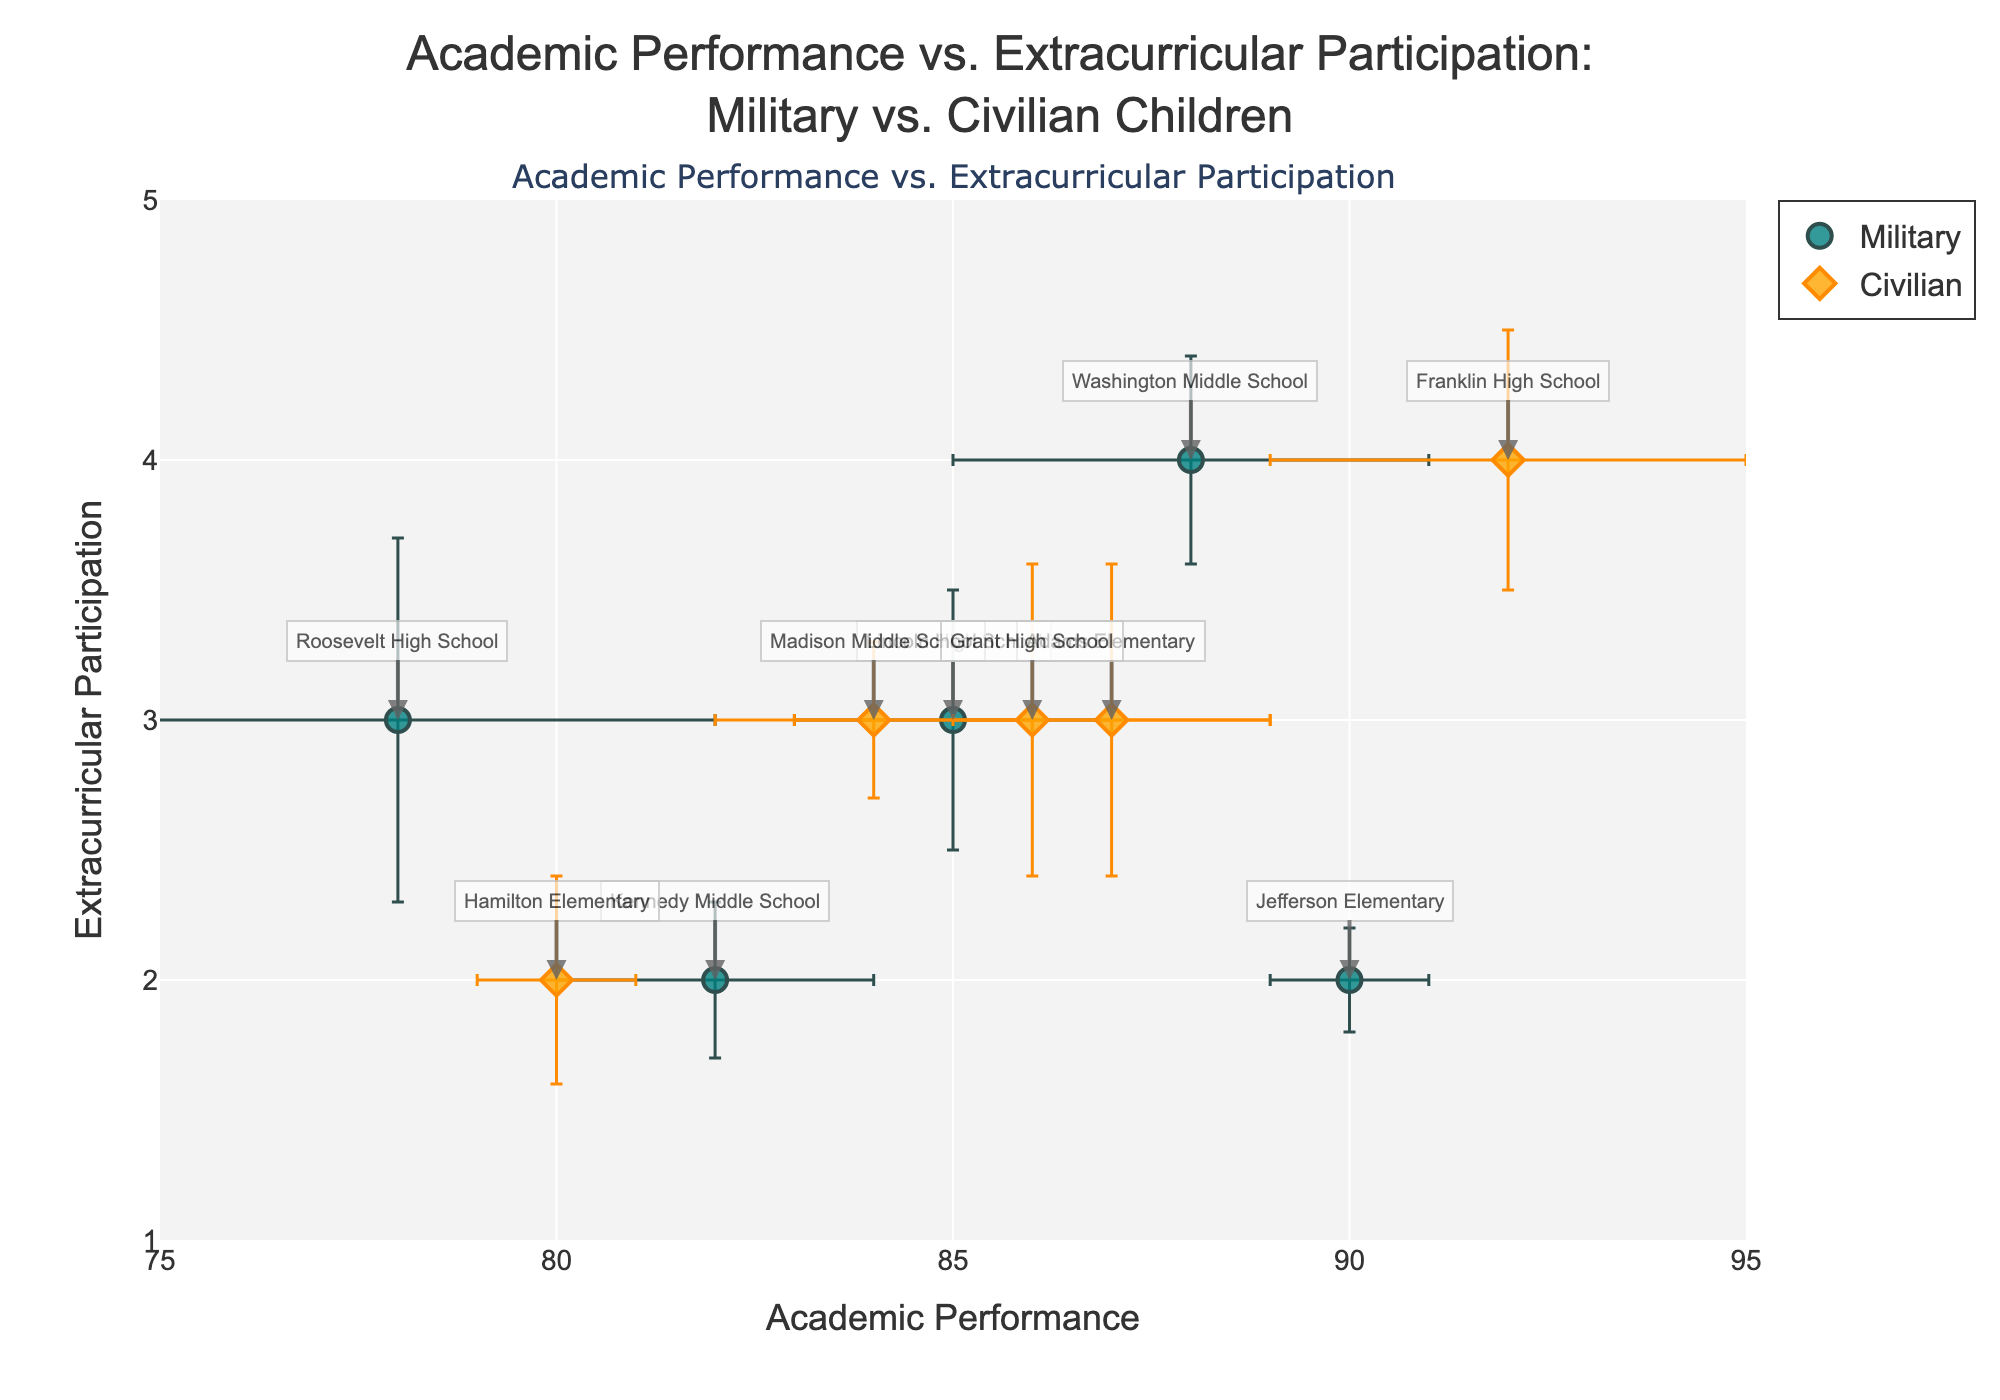How many data points are there for each group in the plot? The plot has markers color-coded for two groups: Military and Civilian. By counting the data points for each, you can see there are 5 markers for the Military group and 5 markers for the Civilian group.
Answer: 5 for Military, 5 for Civilian What is the title of the plot? The plot's title is displayed prominently at the top center of the figure in larger font size. It reads: "Academic Performance vs. Extracurricular Participation: Military vs. Civilian Children."
Answer: Academic Performance vs. Extracurricular Participation: Military vs. Civilian Children Which group generally shows a higher academic performance based on the data points? By examining the x-axis values, which represent Academic Performance, and comparing the general range of markers for both groups, it is observed that Civilian children generally have higher academic performance scores compared to Military children.
Answer: Civilian What school has the highest academic performance and what is its value? Among all the data points, the school with the furthest right x-axis value has the highest Academic Performance. From the annotations, Franklin High School (a Civilian school) has the highest value at 92.
Answer: Franklin High School, 92 Which Military school has the lowest academic performance and what is its value? From the plot, the Military school with the leftmost position on the x-axis represents the lowest Academic Performance. Roosevelt High School shows this value, which is 78.
Answer: Roosevelt High School, 78 Considering both academic performance and extracurricular participation, which Military school has the most balanced performance, i.e., the closest to the center of their group? To find the most balanced performance for the Military group, look for a point that is approximately in the middle of the range for both x and y values among the Military schools. Kennedy Middle School, with an academic performance of 82 and extracurricular participation of 2, seems about centered.
Answer: Kennedy Middle School Which Civilian school has the highest extracurricular participation, and what is its value? By looking at the y-axis, the data point farthest up represents the highest extracurricular participation among Civilian schools, which corresponds to Franklin High School with a value of 4.
Answer: Franklin High School, 4 What are the error bars' range for the Academic Performance of Lincoln High School? To determine the range, take the value of Academic Performance for Lincoln High School, which is 85, and add/subtract the error value, which is 2. Thus, the range is from 83 to 87.
Answer: 83 to 87 Is there a noticeable trend between academic performance and extracurricular participation for either group? By observing the scatter plot, you can look for any visible trend (positive, negative, or none) in each group's markers. No clear trend for Military children is noticeable, but for Civilian children, there appears to be a slight upwards trend suggesting higher academic performance might correlate with higher extracurricular participation.
Answer: Slight upward trend for Civilian, no clear trend for Military In which school does the difference between academic performance and extracurricular participation appear the largest? The difference is largest where the x and y values have the greatest gap. Roosevelt High School (Military) shows the largest difference, with academic performance at 78 and extracurricular participation at 3, making the difference 75.
Answer: Roosevelt High School 